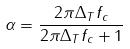<formula> <loc_0><loc_0><loc_500><loc_500>\alpha = \frac { 2 \pi \Delta _ { T } f _ { c } } { 2 \pi \Delta _ { T } f _ { c } + 1 }</formula> 